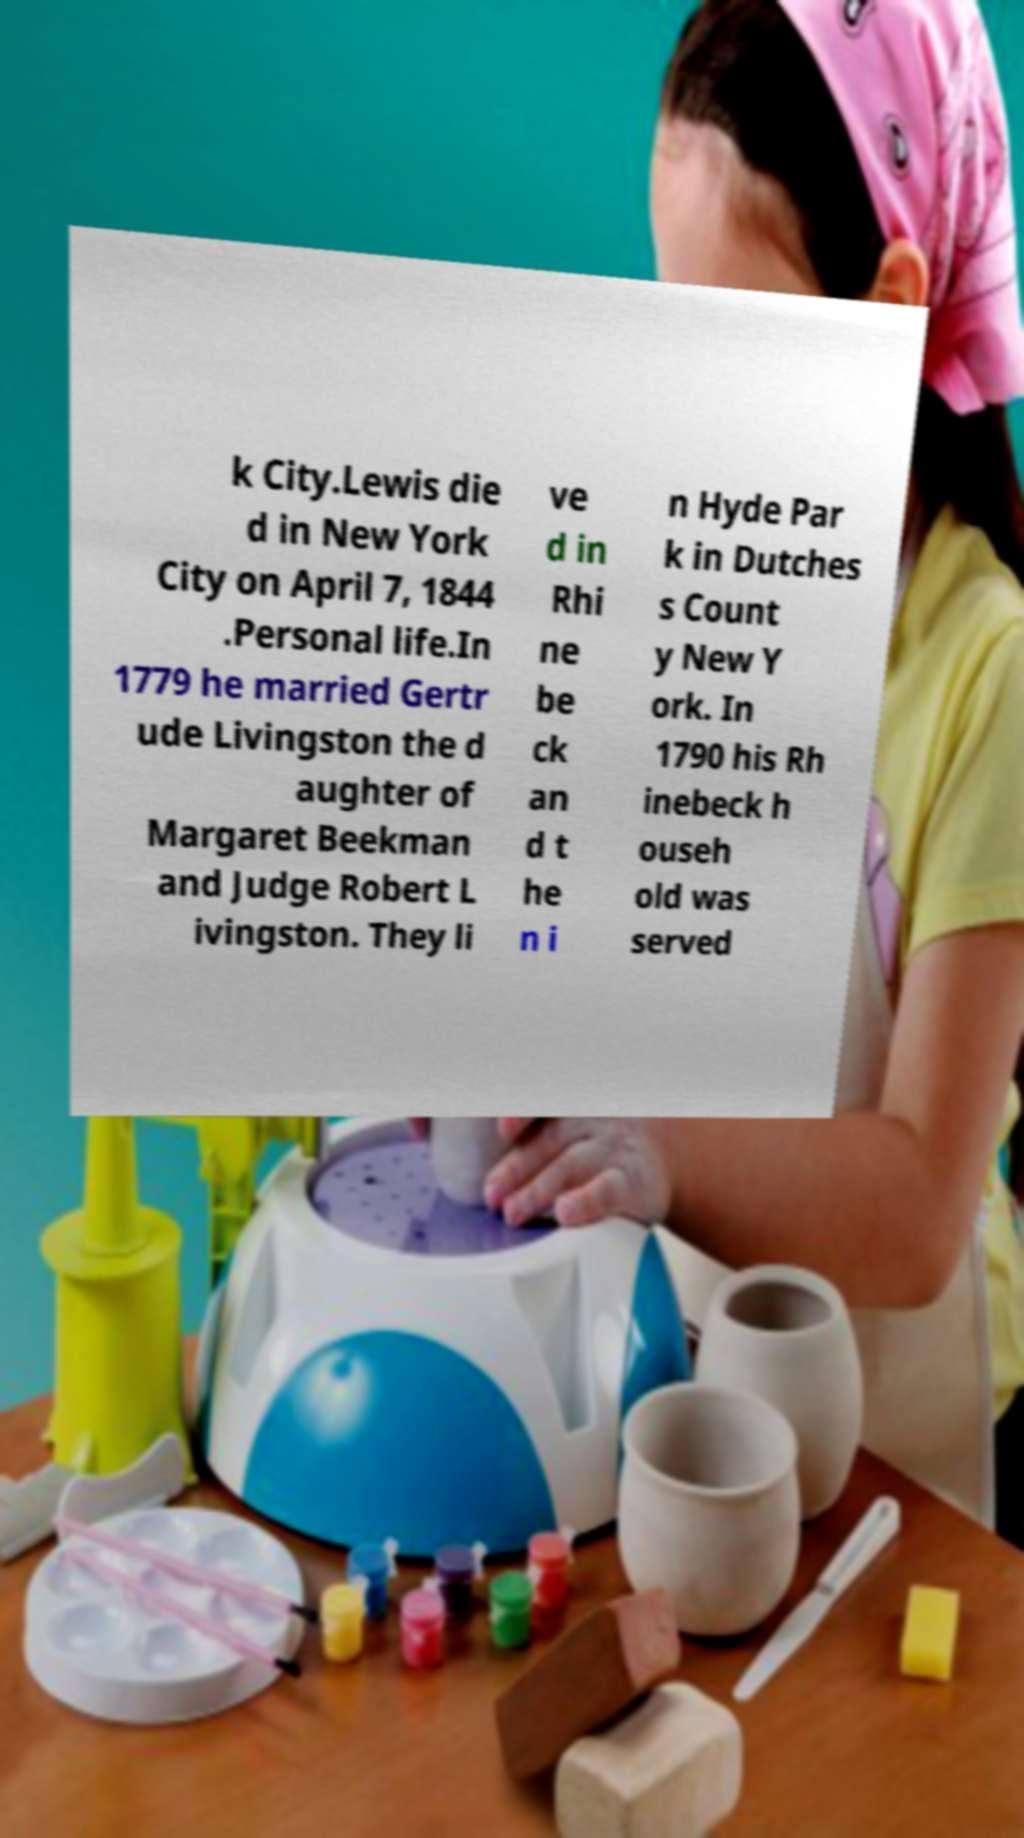For documentation purposes, I need the text within this image transcribed. Could you provide that? k City.Lewis die d in New York City on April 7, 1844 .Personal life.In 1779 he married Gertr ude Livingston the d aughter of Margaret Beekman and Judge Robert L ivingston. They li ve d in Rhi ne be ck an d t he n i n Hyde Par k in Dutches s Count y New Y ork. In 1790 his Rh inebeck h ouseh old was served 